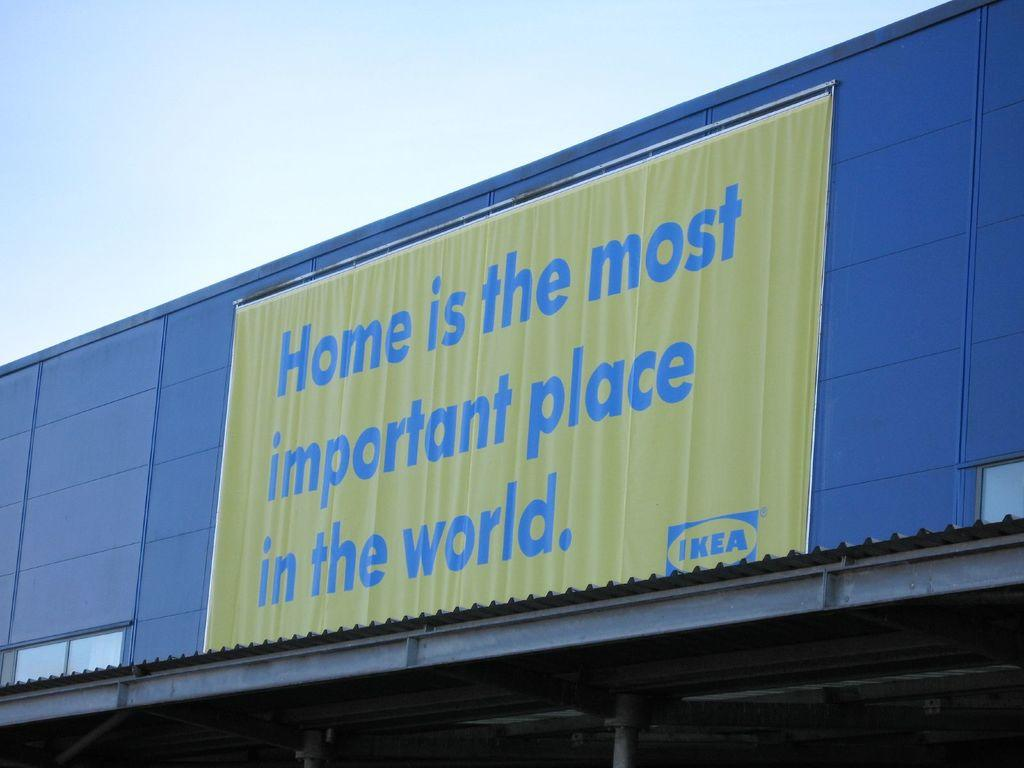<image>
Create a compact narrative representing the image presented. the word Home is on a large sign on a building 